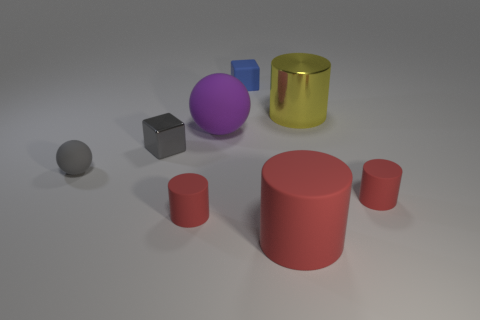There is another thing that is the same color as the small metallic thing; what shape is it?
Your answer should be very brief. Sphere. How many gray cubes are on the right side of the cube that is behind the rubber ball to the right of the gray cube?
Your answer should be very brief. 0. There is a matte object that is in front of the gray matte ball and on the left side of the big matte cylinder; what is its shape?
Make the answer very short. Cylinder. Is the number of gray rubber things to the right of the blue block less than the number of matte cubes?
Ensure brevity in your answer.  Yes. What number of big objects are rubber balls or red things?
Offer a very short reply. 2. How big is the gray metallic block?
Offer a very short reply. Small. How many big red objects are left of the tiny matte sphere?
Your answer should be very brief. 0. What size is the other matte object that is the same shape as the large purple matte thing?
Offer a very short reply. Small. There is a cylinder that is both behind the large red cylinder and to the left of the yellow cylinder; what is its size?
Your answer should be compact. Small. Does the small metal block have the same color as the tiny ball in front of the metal cylinder?
Provide a short and direct response. Yes. 